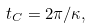Convert formula to latex. <formula><loc_0><loc_0><loc_500><loc_500>t _ { C } = 2 \pi / \kappa ,</formula> 